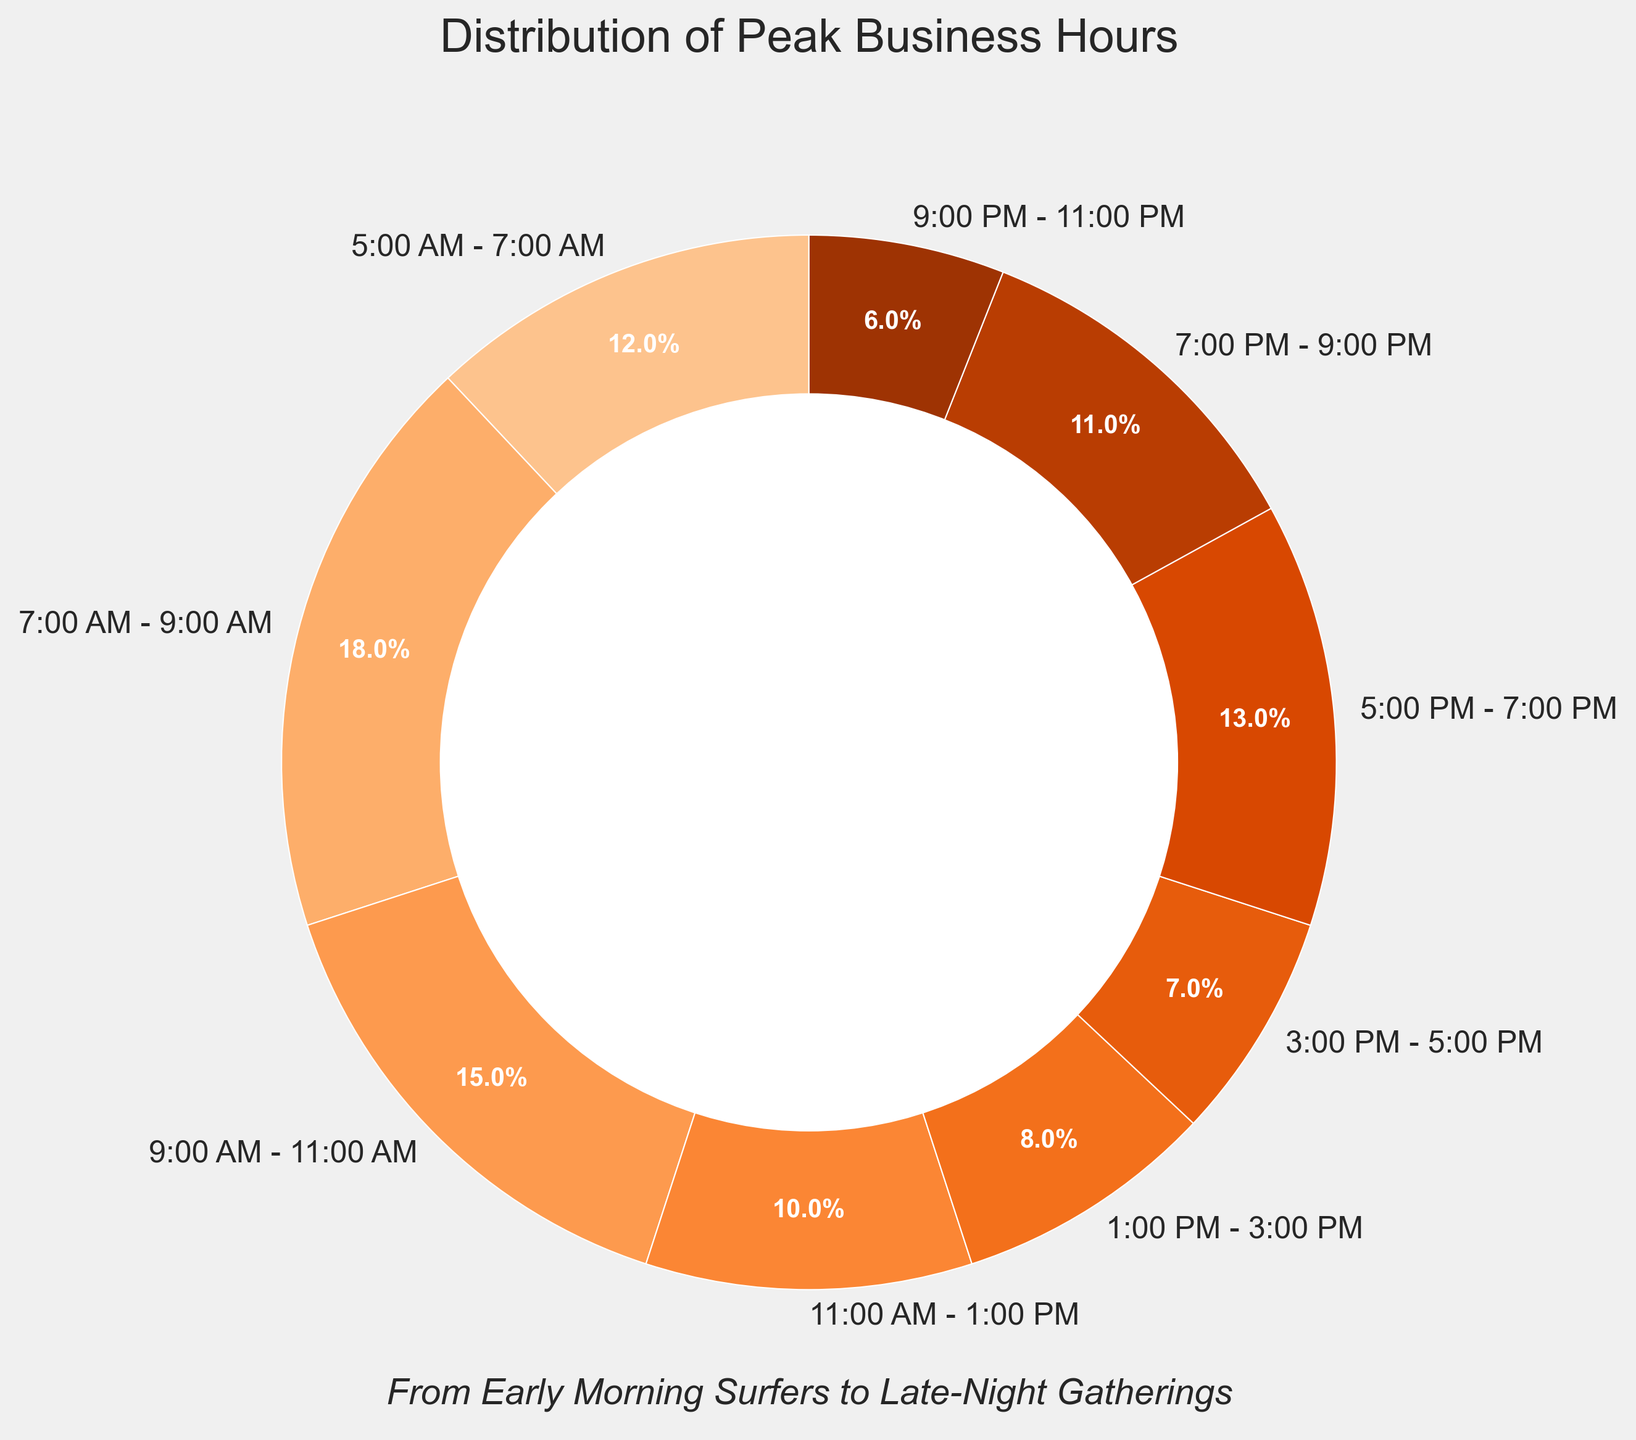Which time range has the highest percentage of peak business hours? The largest section of the pie chart corresponds to the time range 7:00 AM - 9:00 AM, which shows a percentage of 18%.
Answer: 7:00 AM - 9:00 AM Which two time ranges combined contribute to 25% of the peak business hours? The time ranges 5:00 AM - 7:00 AM and 9:00 AM - 11:00 AM, which contribute 12% and 15% respectively, sum up to 27%, not 25%. Alternatively, 3:00 PM - 5:00 PM (7%) and 5:00 PM - 7:00 PM (13%) add up to 20%, which isn't 25% either. However, 5:00 PM - 7:00 PM (13%) plus 7:00 PM - 9:00 PM (11%) add up to 24%, close but not exact. For an exact 25%, no two combinations match.
Answer: Not Applicable What is the difference in peak business hours between 7:00 AM - 9:00 AM and 3:00 PM - 5:00 PM? To find the difference, subtract the percentage for 3:00 PM - 5:00 PM (7%) from the percentage for 7:00 AM - 9:00 AM (18%). 18% - 7% = 11%.
Answer: 11% Which time range has a lower percentage of peak business hours: 11:00 AM - 1:00 PM or 7:00 PM - 9:00 PM? According to the pie chart, 11:00 AM - 1:00 PM has 10%, and 7:00 PM - 9:00 PM has 11%. 10% is less than 11%.
Answer: 11:00 AM - 1:00 PM How many time ranges have a percentage of peak business hours greater than 10%? The time ranges with percentages greater than 10% are 5:00 AM - 7:00 AM (12%), 7:00 AM - 9:00 AM (18%), 9:00 AM - 11:00 AM (15%), 5:00 PM - 7:00 PM (13%), and 7:00 PM - 9:00 PM (11%). Counting these gives a total of five time ranges.
Answer: 5 What is the total percentage of peak business hours from 5:00 AM to 11:00 AM? The time ranges from 5:00 AM to 11:00 AM are 5:00 AM - 7:00 AM (12%), 7:00 AM - 9:00 AM (18%), and 9:00 AM - 11:00 AM (15%). Adding these percentages gives 12% + 18% + 15% = 45%.
Answer: 45% Which time ranges contribute the least to the peak business hours? The smallest sections of the pie chart correspond to the time ranges 3:00 PM - 5:00 PM (7%) and 9:00 PM - 11:00 PM (6%).
Answer: 3:00 PM - 5:00 PM and 9:00 PM - 11:00 PM What is the cumulative percentage of business hours from 5:00 PM to 11:00 PM? The time ranges from 5:00 PM to 11:00 PM are 5:00 PM - 7:00 PM (13%), 7:00 PM - 9:00 PM (11%), and 9:00 PM - 11:00 PM (6%). Adding these percentages gives 13% + 11% + 6% = 30%.
Answer: 30% Is the percentage of peak business hours between 5:00 PM - 7:00 PM higher or lower than the percentage between 5:00 AM - 7:00 AM? The percentage for 5:00 AM - 7:00 AM is 12%, and for 5:00 PM - 7:00 PM it is 13%. Therefore, 5:00 PM - 7:00 PM has a slightly higher percentage.
Answer: Higher 